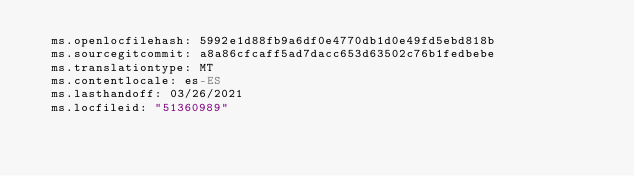<code> <loc_0><loc_0><loc_500><loc_500><_YAML_>  ms.openlocfilehash: 5992e1d88fb9a6df0e4770db1d0e49fd5ebd818b
  ms.sourcegitcommit: a8a86cfcaff5ad7dacc653d63502c76b1fedbebe
  ms.translationtype: MT
  ms.contentlocale: es-ES
  ms.lasthandoff: 03/26/2021
  ms.locfileid: "51360989"
</code> 